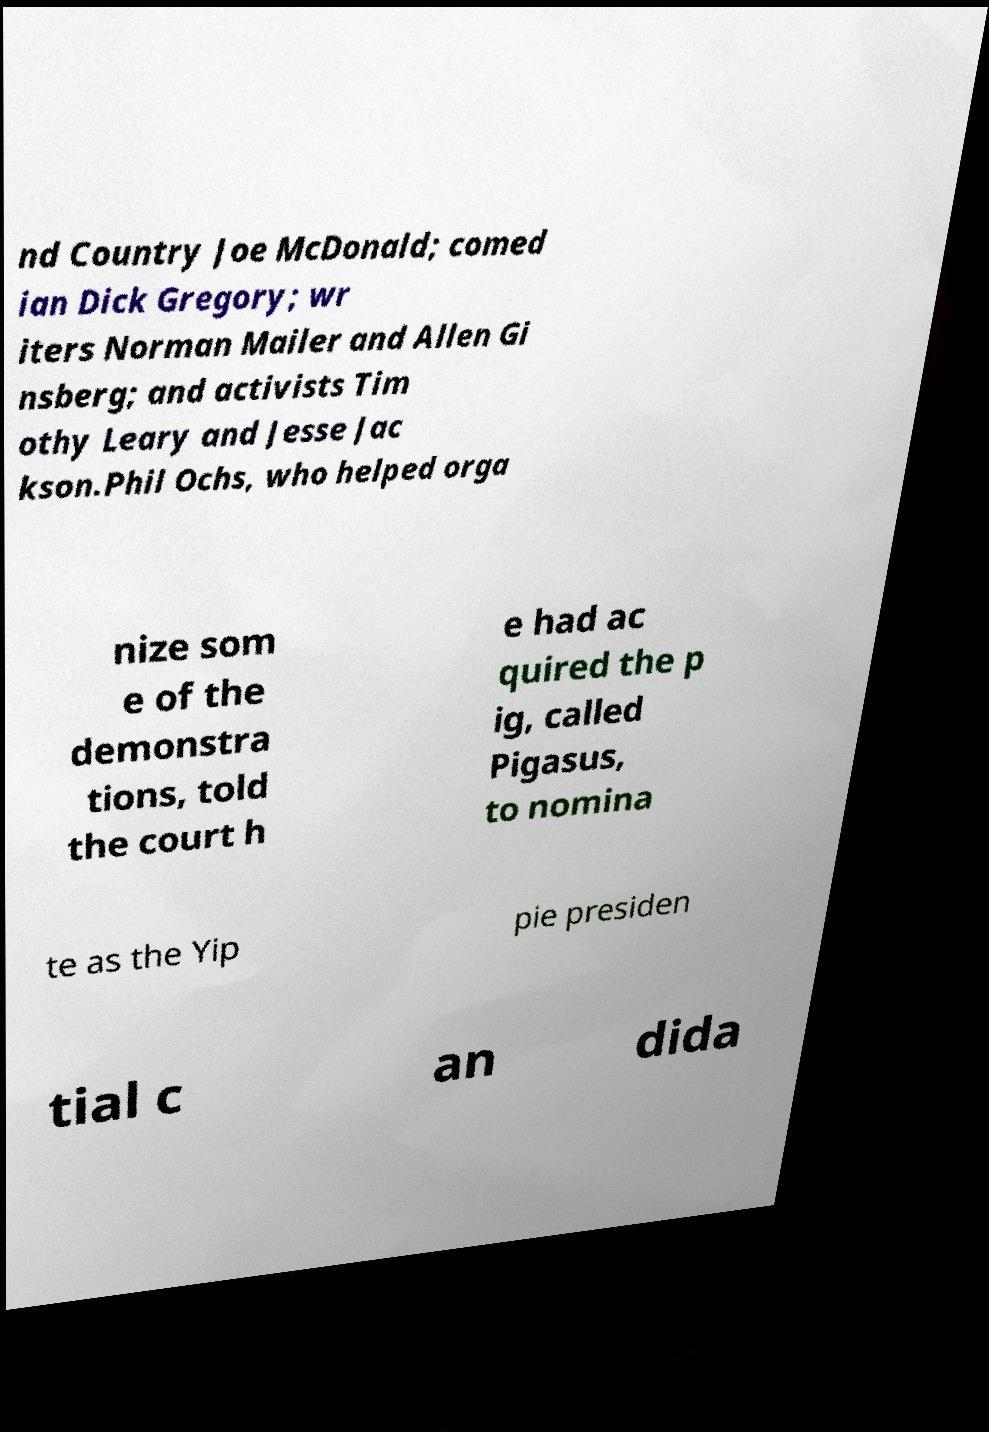Could you assist in decoding the text presented in this image and type it out clearly? nd Country Joe McDonald; comed ian Dick Gregory; wr iters Norman Mailer and Allen Gi nsberg; and activists Tim othy Leary and Jesse Jac kson.Phil Ochs, who helped orga nize som e of the demonstra tions, told the court h e had ac quired the p ig, called Pigasus, to nomina te as the Yip pie presiden tial c an dida 